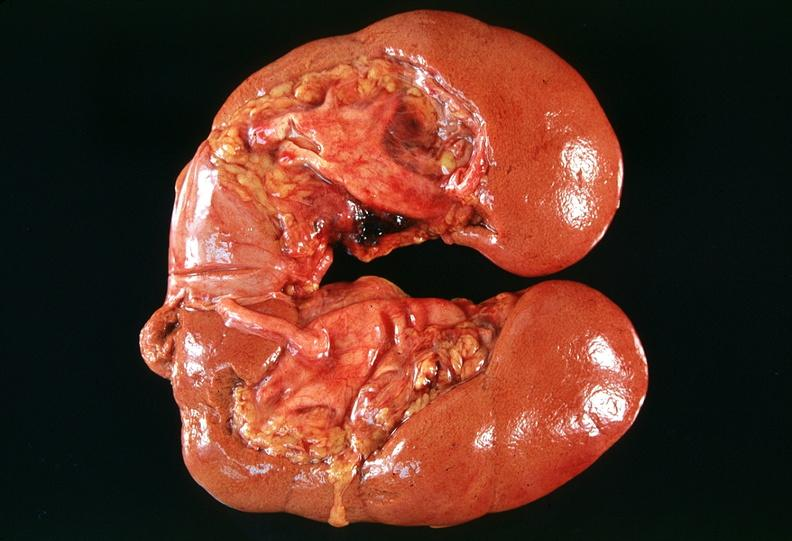where is this?
Answer the question using a single word or phrase. Urinary 